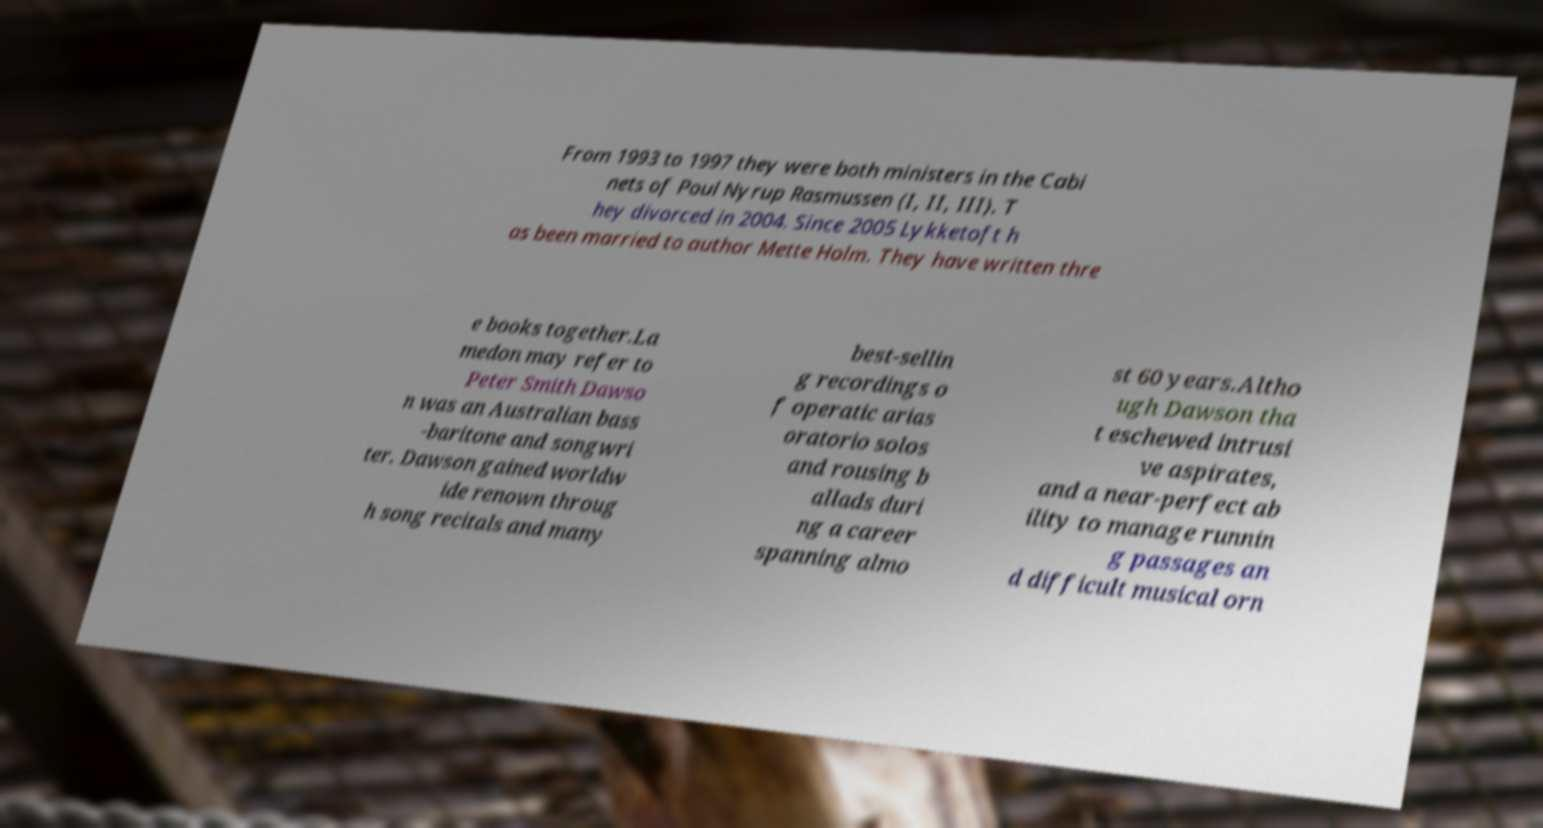I need the written content from this picture converted into text. Can you do that? From 1993 to 1997 they were both ministers in the Cabi nets of Poul Nyrup Rasmussen (I, II, III). T hey divorced in 2004. Since 2005 Lykketoft h as been married to author Mette Holm. They have written thre e books together.La medon may refer to Peter Smith Dawso n was an Australian bass -baritone and songwri ter. Dawson gained worldw ide renown throug h song recitals and many best-sellin g recordings o f operatic arias oratorio solos and rousing b allads duri ng a career spanning almo st 60 years.Altho ugh Dawson tha t eschewed intrusi ve aspirates, and a near-perfect ab ility to manage runnin g passages an d difficult musical orn 